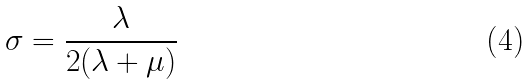<formula> <loc_0><loc_0><loc_500><loc_500>\sigma = \frac { \lambda } { 2 ( \lambda + \mu ) }</formula> 